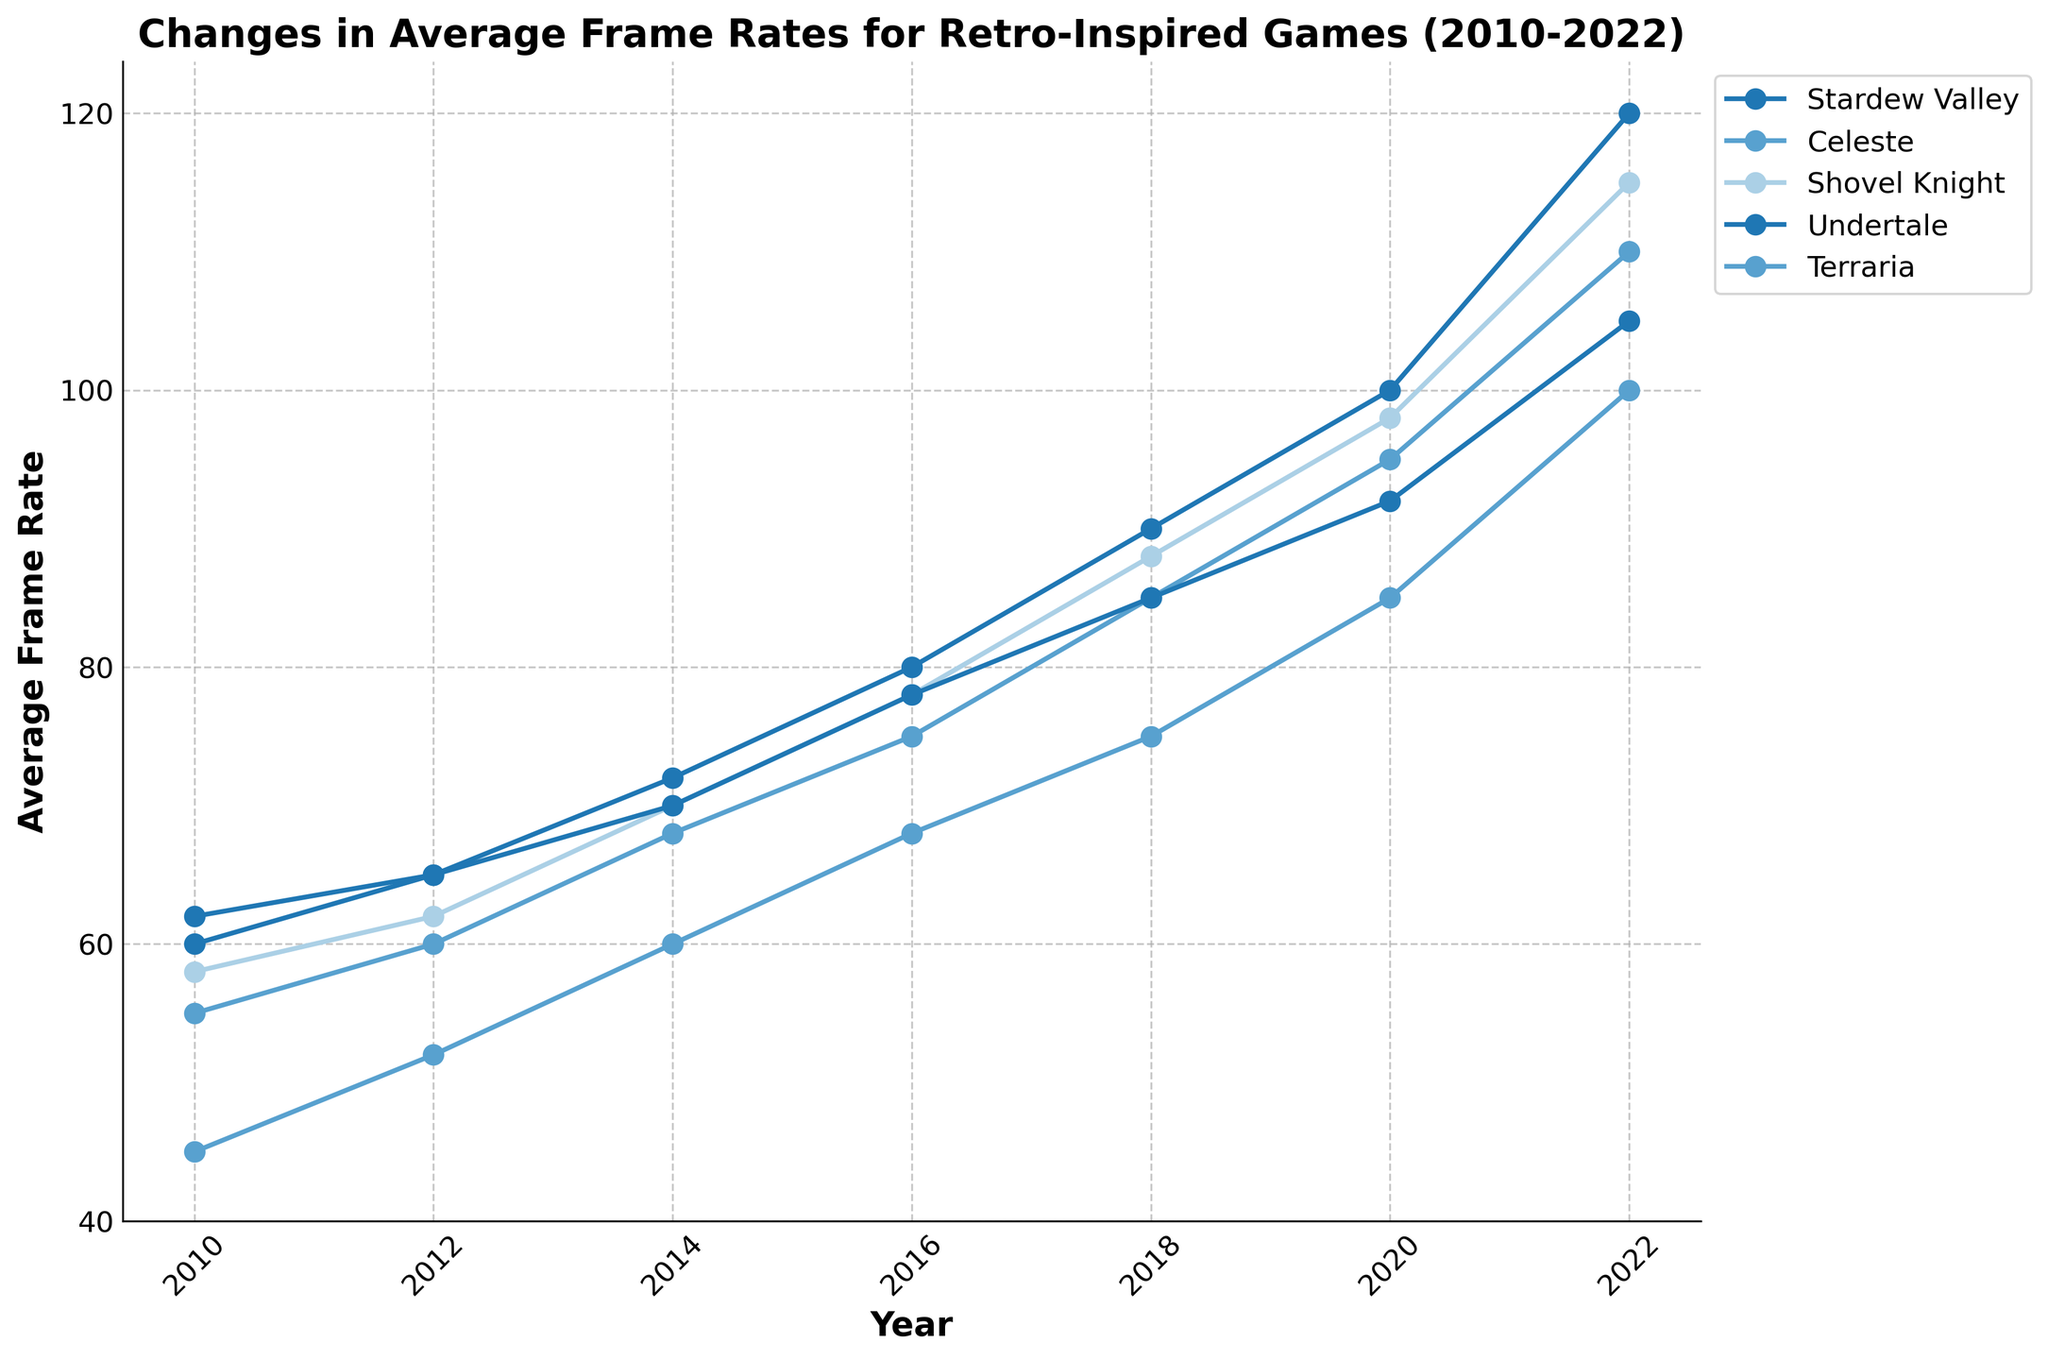What happened to the average frame rates of Terraria from 2010 to 2022? To find the frame rate change, look at Terraria's data points in 2010 and 2022. The frame rate increased from 45 in 2010 to 100 in 2022.
Answer: Increased from 45 to 100 Which game had the highest average frame rate in 2022? Look at the frame rates for all games in 2022: Stardew Valley (120), Celeste (110), Shovel Knight (115), Undertale (105), Terraria (100). Stardew Valley had the highest.
Answer: Stardew Valley Between Stardew Valley and Celeste, which game showed a greater increase in average frame rates between 2014 and 2022? Calculate the increase for Stardew Valley from 72 to 120 (48) and for Celeste from 68 to 110 (42). Stardew Valley had a greater increase.
Answer: Stardew Valley On average, how much did Shovel Knight's frame rate increase per year from 2010 to 2022? Shovel Knight's frame rate increased from 58 in 2010 to 115 in 2022. The total increase is 57 over 12 years. 57/12 ≈ 4.75 fps/year.
Answer: 4.75 fps/year What is the overall trend in average frame rates for the games shown in the figure from 2010 to 2022? All lines in the chart show an upward trend over the years, indicating increasing frame rates for each game.
Answer: Increasing trend Which game had the smallest increase in frame rate from 2010 to 2022? Compare the frame rate changes for each game: Stardew Valley (60 to 120, +60), Celeste (55 to 110, +55), Shovel Knight (58 to 115, +57), Undertale (62 to 105, +43), Terraria (45 to 100, +55). Undertale had the smallest increase.
Answer: Undertale What is the difference in frame rates between Stardew Valley and Celeste in 2020? Subtract Celeste's frame rate from Stardew Valley's frame rate in 2020: 100 - 95 = 5 fps.
Answer: 5 fps During which year did Shovel Knight experience the most significant increase in frame rate? Compare the frame rate increases year by year for Shovel Knight: 2010-2012 (58 to 62, +4), 2012-2014 (62 to 70, +8), 2014-2016 (70 to 78, +8), 2016-2018 (78 to 88, +10), 2018-2020 (88 to 98, +10), 2020-2022 (98 to 115, +17). The most significant increase happened in 2020-2022.
Answer: 2020-2022 Which game had the most stable increase in average frame rate over the years 2010 to 2022? Examine the slope of the lines for each game over the years. The lines with the least variation in slope represent stable increases. Stardew Valley shows a mostly consistent slope throughout the years.
Answer: Stardew Valley What was the average frame rate of all the games combined in 2016? Sum the frame rates for all games in 2016 and divide by the number of games: (80 + 75 + 78 + 78 + 68) / 5 = 379 / 5 = 75.8 fps.
Answer: 75.8 fps 